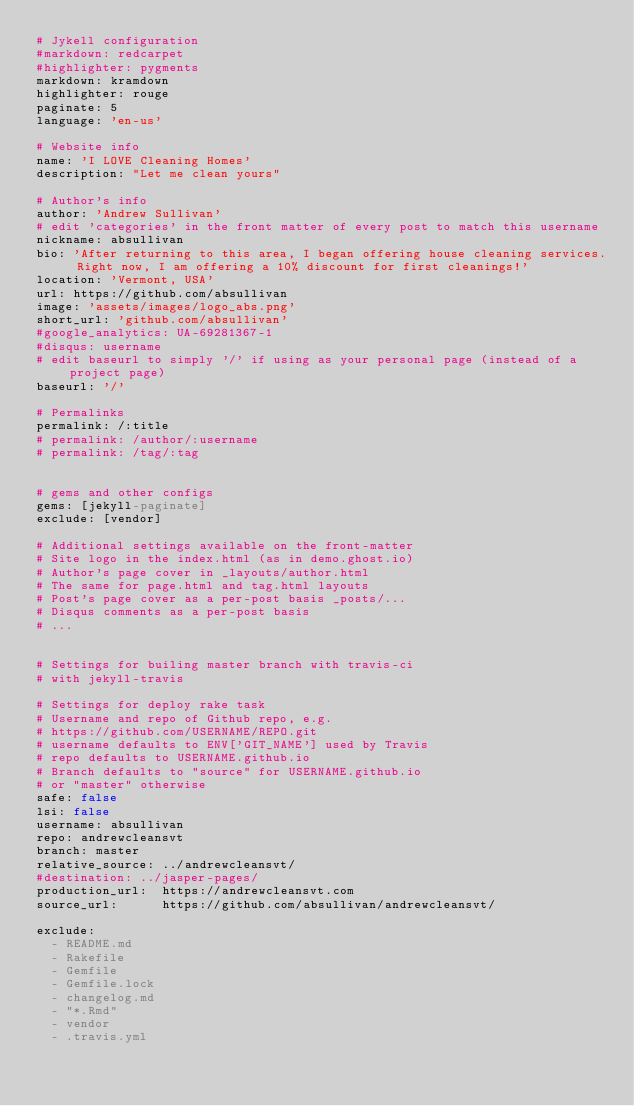Convert code to text. <code><loc_0><loc_0><loc_500><loc_500><_YAML_># Jykell configuration
#markdown: redcarpet
#highlighter: pygments
markdown: kramdown
highlighter: rouge
paginate: 5
language: 'en-us'

# Website info
name: 'I LOVE Cleaning Homes'
description: "Let me clean yours"

# Author's info
author: 'Andrew Sullivan'
# edit 'categories' in the front matter of every post to match this username
nickname: absullivan
bio: 'After returning to this area, I began offering house cleaning services. Right now, I am offering a 10% discount for first cleanings!'
location: 'Vermont, USA'
url: https://github.com/absullivan
image: 'assets/images/logo_abs.png'
short_url: 'github.com/absullivan'
#google_analytics: UA-69281367-1
#disqus: username
# edit baseurl to simply '/' if using as your personal page (instead of a project page)
baseurl: '/'

# Permalinks
permalink: /:title
# permalink: /author/:username
# permalink: /tag/:tag


# gems and other configs
gems: [jekyll-paginate]
exclude: [vendor]

# Additional settings available on the front-matter
# Site logo in the index.html (as in demo.ghost.io)
# Author's page cover in _layouts/author.html
# The same for page.html and tag.html layouts
# Post's page cover as a per-post basis _posts/...
# Disqus comments as a per-post basis
# ...


# Settings for builing master branch with travis-ci
# with jekyll-travis

# Settings for deploy rake task
# Username and repo of Github repo, e.g.
# https://github.com/USERNAME/REPO.git
# username defaults to ENV['GIT_NAME'] used by Travis
# repo defaults to USERNAME.github.io
# Branch defaults to "source" for USERNAME.github.io
# or "master" otherwise
safe: false
lsi: false
username: absullivan
repo: andrewcleansvt
branch: master
relative_source: ../andrewcleansvt/
#destination: ../jasper-pages/
production_url:  https://andrewcleansvt.com
source_url:      https://github.com/absullivan/andrewcleansvt/

exclude:
  - README.md
  - Rakefile
  - Gemfile
  - Gemfile.lock
  - changelog.md
  - "*.Rmd"
  - vendor
  - .travis.yml
</code> 